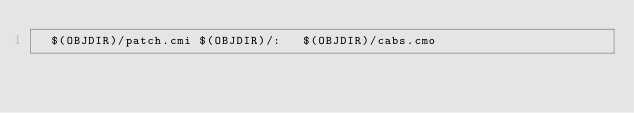Convert code to text. <code><loc_0><loc_0><loc_500><loc_500><_D_>  $(OBJDIR)/patch.cmi $(OBJDIR)/:   $(OBJDIR)/cabs.cmo
</code> 